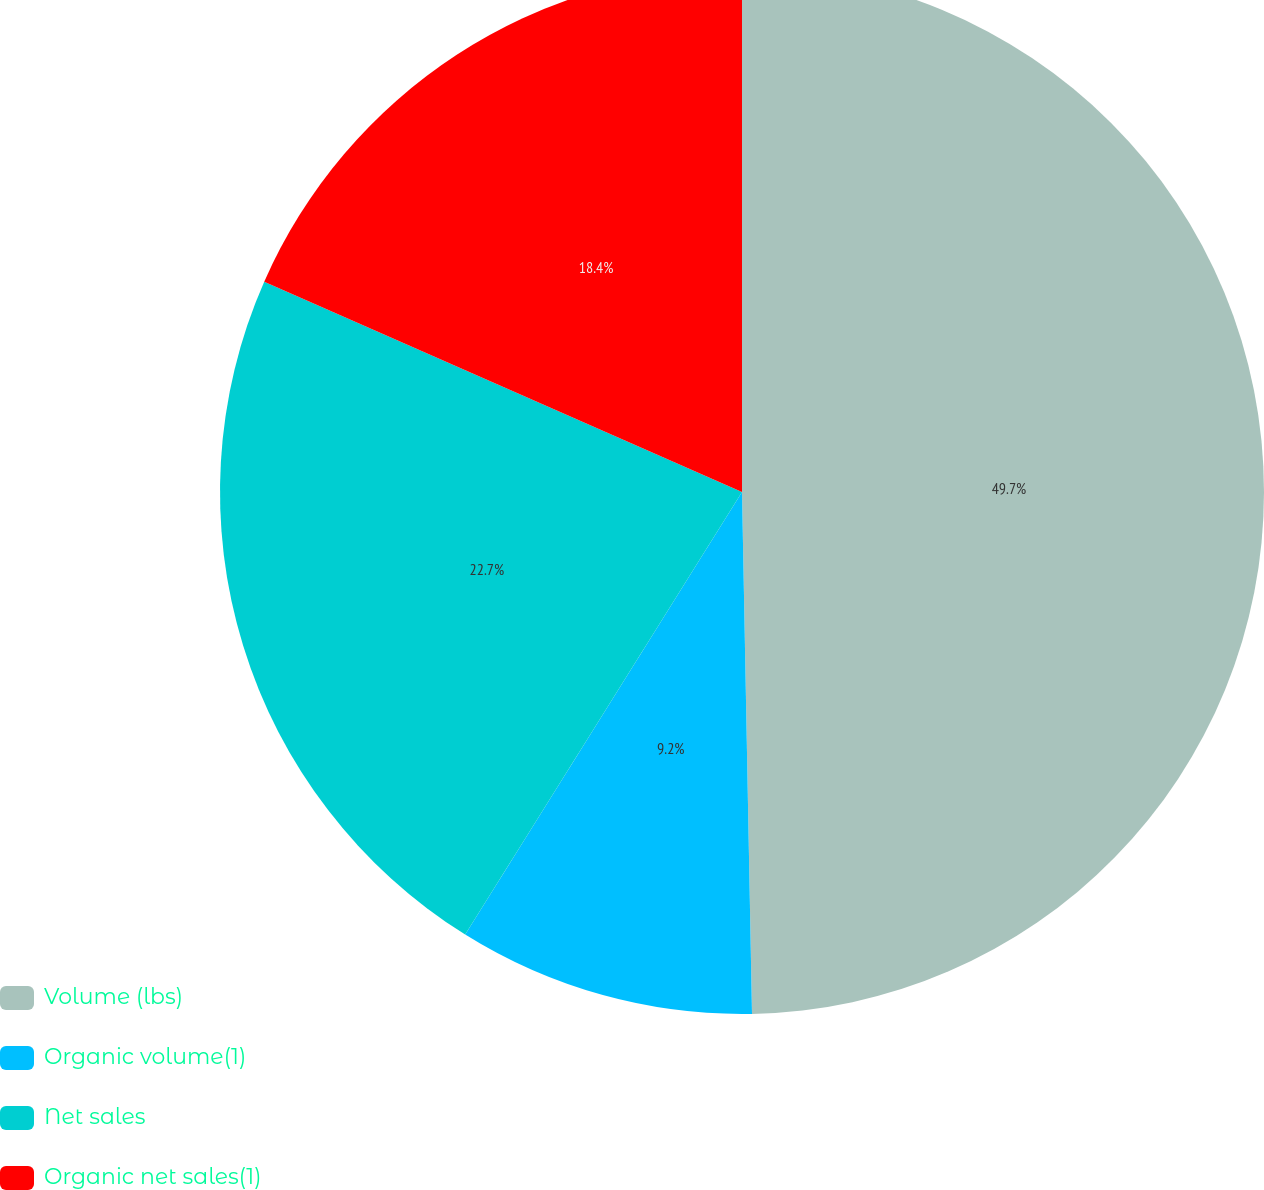<chart> <loc_0><loc_0><loc_500><loc_500><pie_chart><fcel>Volume (lbs)<fcel>Organic volume(1)<fcel>Net sales<fcel>Organic net sales(1)<nl><fcel>49.69%<fcel>9.2%<fcel>22.7%<fcel>18.4%<nl></chart> 